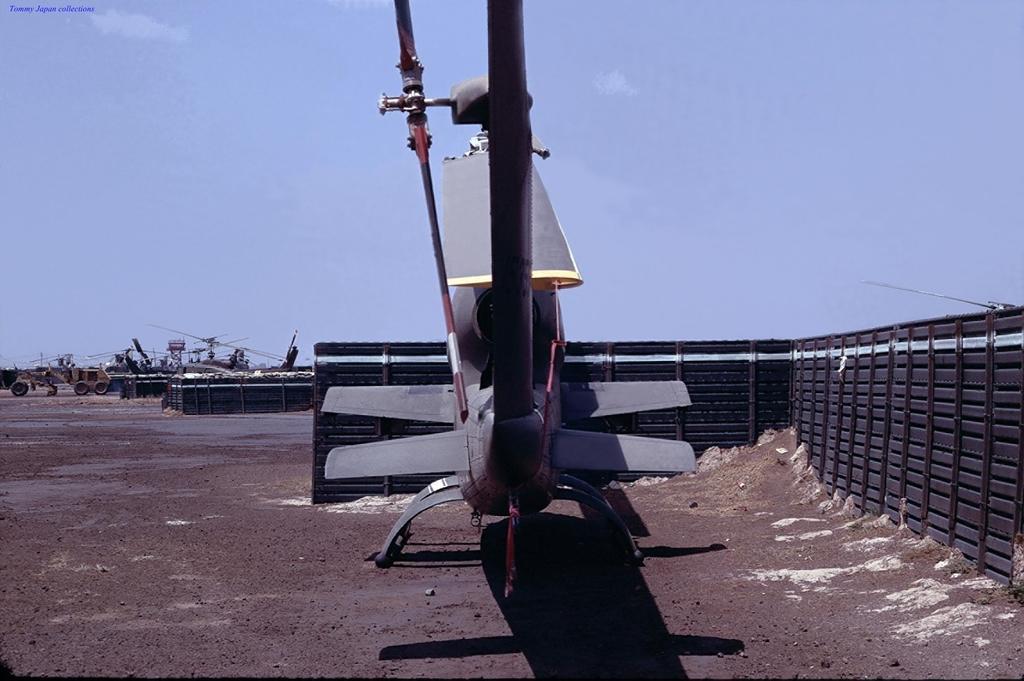How would you summarize this image in a sentence or two? In this picture we can see few vehicles, helicopters on the ground, beside to the vehicles we can find fence, on left top corner we can see a watermark. 